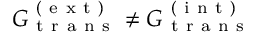<formula> <loc_0><loc_0><loc_500><loc_500>G _ { t r a n s } ^ { ( e x t ) } \neq G _ { t r a n s } ^ { ( i n t ) }</formula> 